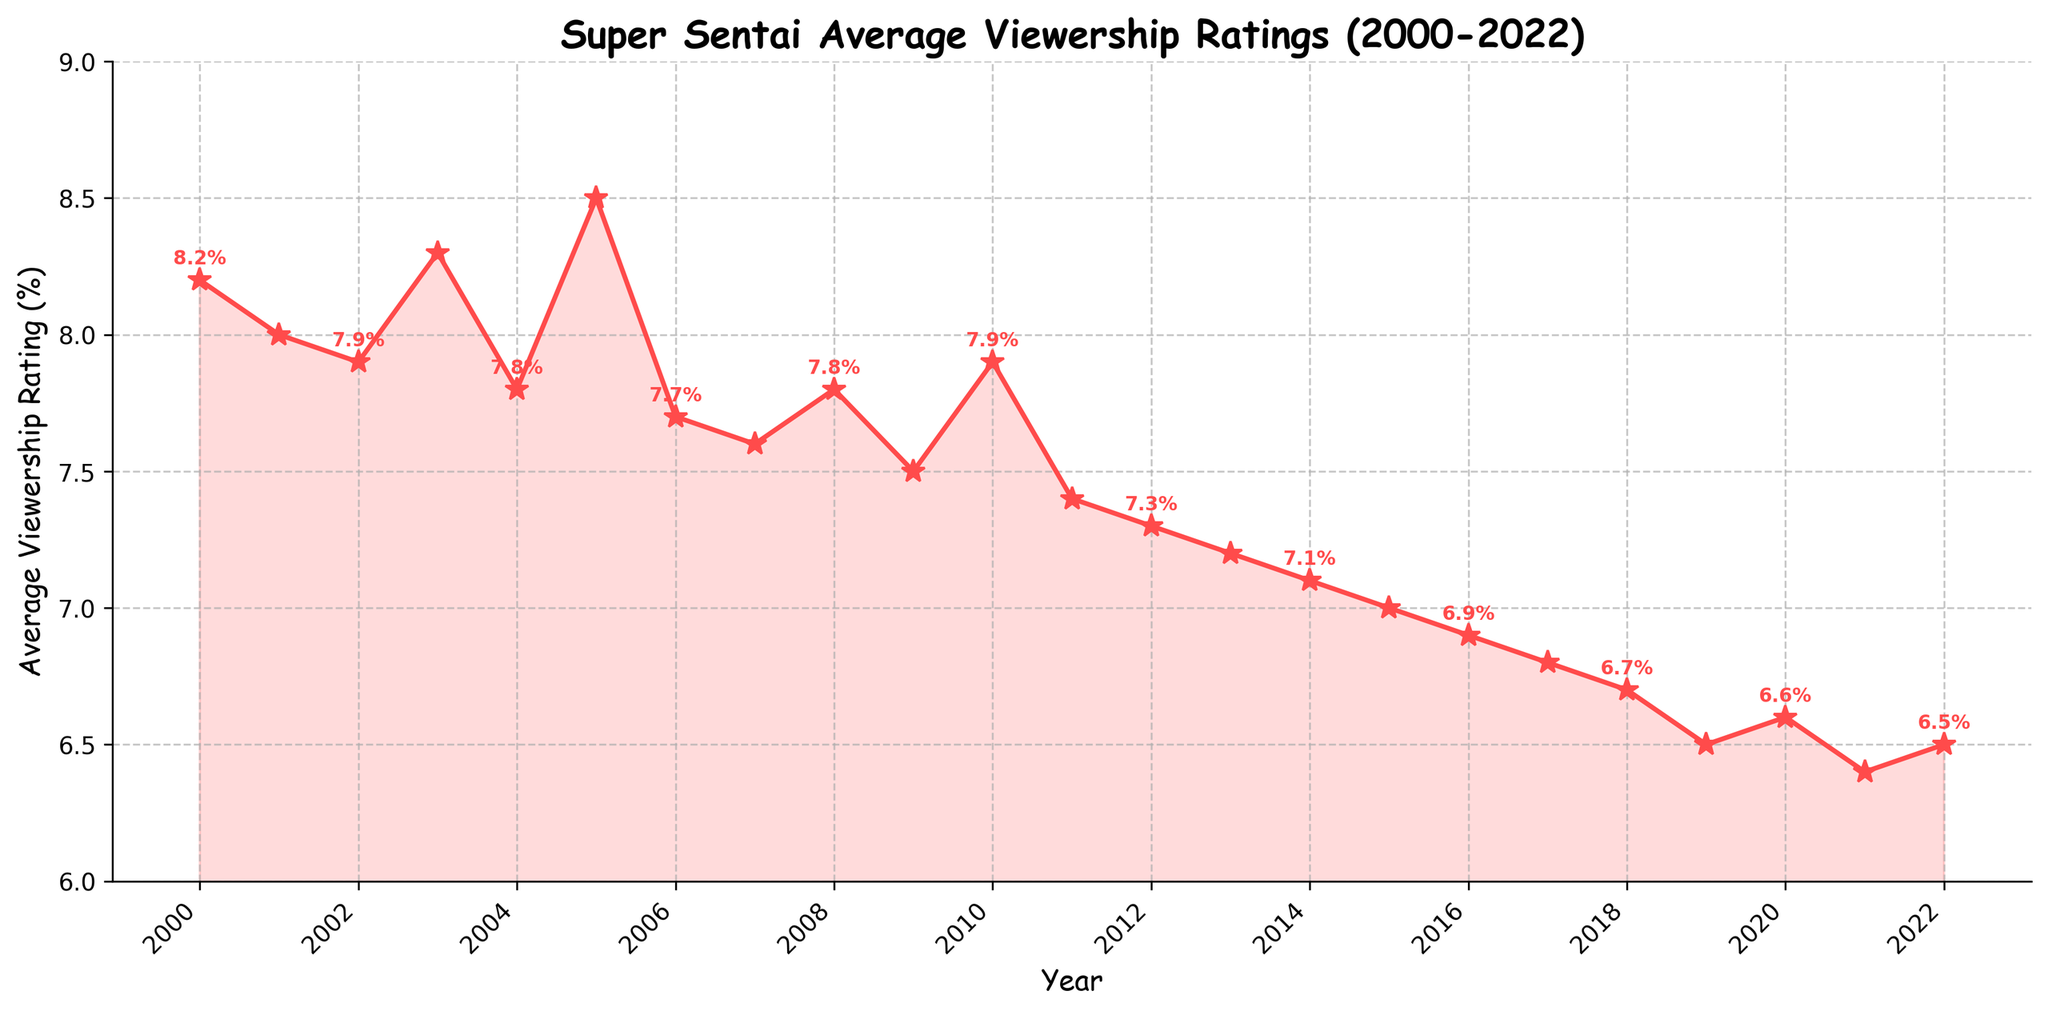what is the title of the plot? The title is shown at the top of the figure, which is bold and in a readable font. The title is "Super Sentai Average Viewership Ratings (2000-2022)"
Answer: Super Sentai Average Viewership Ratings (2000-2022) In which year did 'Super Sentai' receive the highest viewership rating? By looking at the plot, find the point that reaches the highest value on the y-axis. This point is in 2005 with an average viewership rating of 8.5%.
Answer: 2005 What is the average viewership rating in 2006? Locate the point corresponding to the year 2006 on the x-axis and identify the viewership rating on the y-axis, which is 7.7%.
Answer: 7.7% Between which two consecutive years did the average viewership rating decrease the most? Examine the drops between consecutive years and identify the largest decrease. The largest drop is between 2004 (8.3%) and 2005 (7.7%), which decreases by 0.6%.
Answer: 2004-2005 Which year had the lowest viewership rating? Examine the bottom-most points on the y-axis, and identify the year that corresponds to 6.4% which is in 2021.
Answer: 2021 How did the average viewership rating change from 2018 to 2020? From 2018 (6.7%) to 2019 (6.5%) it decreased by 0.2, and from 2019 (6.5%) to 2020 (6.6%) it increased by 0.1. In total, it decreased by 0.1.
Answer: Decrease by 0.1 Calculate the average viewership rating from 2015 to 2020. Sum viewership ratings from 2015 to 2020 and then divide by the number of years (7.0 + 6.9 + 6.8 + 6.7 + 6.5 + 6.6 = 40.5). There are six years, so 40.5 / 6 = 6.75.
Answer: 6.75 How many years had a viewership rating above 7.0? Count the number of points on the plot where the y-value is greater than 7.0. These points correspond to the years 2000 through 2010 and in 2013, totaling 12 years.
Answer: 12 What trend is noticeable from 2010 onward in the average viewership ratings? Observe the line from 2010 to 2022, it generally shows a downward trend which means the ratings have been decreasing.
Answer: Decreasing trend What is the percentage difference between the highest and lowest viewership ratings? Calculate the difference between the highest rating (8.5%) and the lowest rating (6.4%) which is 2.1%. The percentage difference is calculated as (2.1/8.5)*100% = 24.7%.
Answer: 24.7% 